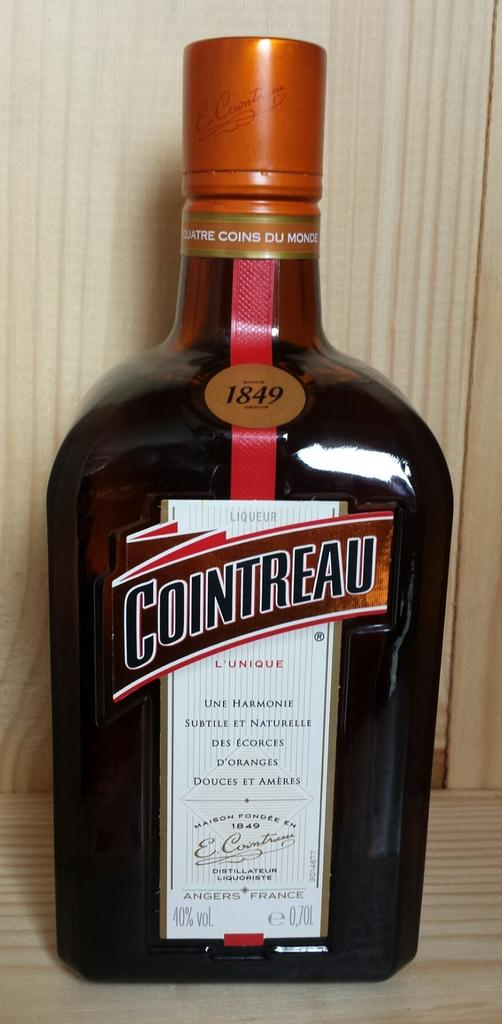<image>
Summarize the visual content of the image. A sealed .70L bottle of 1849 Cointreau liquor. 